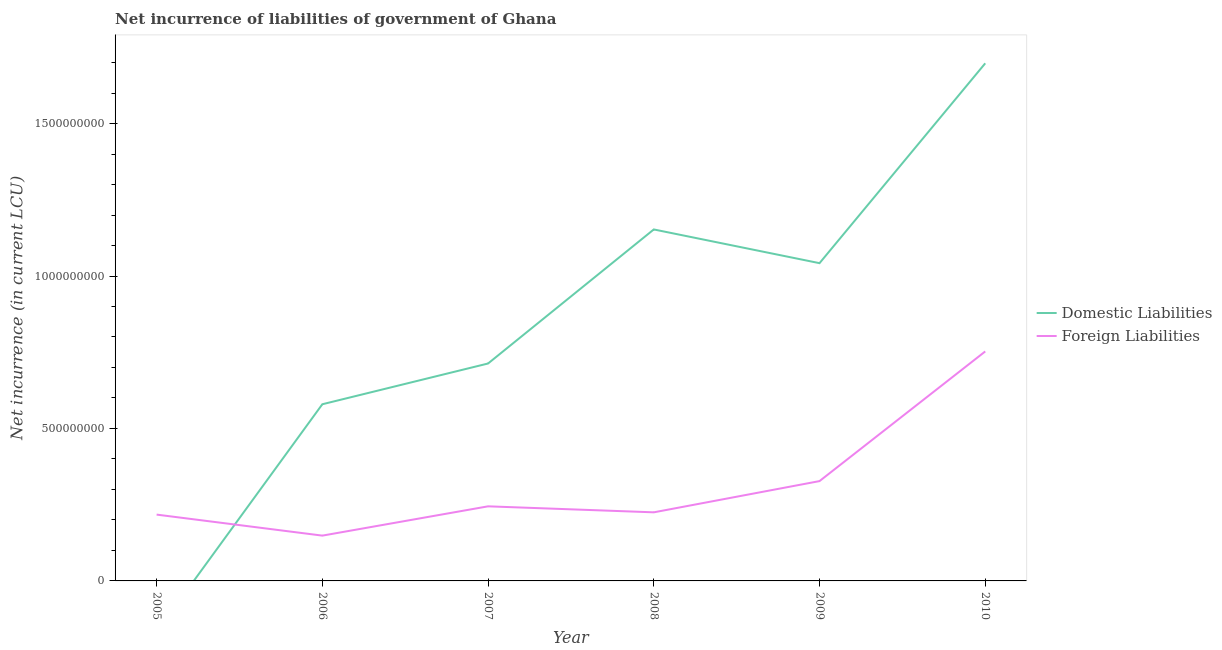How many different coloured lines are there?
Give a very brief answer. 2. Does the line corresponding to net incurrence of foreign liabilities intersect with the line corresponding to net incurrence of domestic liabilities?
Make the answer very short. Yes. Is the number of lines equal to the number of legend labels?
Your answer should be very brief. No. What is the net incurrence of foreign liabilities in 2005?
Offer a very short reply. 2.17e+08. Across all years, what is the maximum net incurrence of domestic liabilities?
Provide a succinct answer. 1.70e+09. Across all years, what is the minimum net incurrence of foreign liabilities?
Ensure brevity in your answer.  1.49e+08. In which year was the net incurrence of domestic liabilities maximum?
Your response must be concise. 2010. What is the total net incurrence of domestic liabilities in the graph?
Your answer should be compact. 5.18e+09. What is the difference between the net incurrence of foreign liabilities in 2006 and that in 2009?
Offer a very short reply. -1.79e+08. What is the difference between the net incurrence of foreign liabilities in 2009 and the net incurrence of domestic liabilities in 2010?
Keep it short and to the point. -1.37e+09. What is the average net incurrence of foreign liabilities per year?
Your answer should be compact. 3.19e+08. In the year 2010, what is the difference between the net incurrence of domestic liabilities and net incurrence of foreign liabilities?
Offer a terse response. 9.45e+08. In how many years, is the net incurrence of domestic liabilities greater than 500000000 LCU?
Your answer should be very brief. 5. What is the ratio of the net incurrence of domestic liabilities in 2007 to that in 2010?
Give a very brief answer. 0.42. Is the net incurrence of foreign liabilities in 2005 less than that in 2007?
Ensure brevity in your answer.  Yes. Is the difference between the net incurrence of domestic liabilities in 2006 and 2009 greater than the difference between the net incurrence of foreign liabilities in 2006 and 2009?
Provide a short and direct response. No. What is the difference between the highest and the second highest net incurrence of domestic liabilities?
Keep it short and to the point. 5.45e+08. What is the difference between the highest and the lowest net incurrence of domestic liabilities?
Keep it short and to the point. 1.70e+09. In how many years, is the net incurrence of foreign liabilities greater than the average net incurrence of foreign liabilities taken over all years?
Your response must be concise. 2. Is the net incurrence of domestic liabilities strictly greater than the net incurrence of foreign liabilities over the years?
Your answer should be very brief. No. Is the net incurrence of domestic liabilities strictly less than the net incurrence of foreign liabilities over the years?
Your response must be concise. No. How many lines are there?
Offer a very short reply. 2. How many years are there in the graph?
Keep it short and to the point. 6. How many legend labels are there?
Offer a terse response. 2. What is the title of the graph?
Your response must be concise. Net incurrence of liabilities of government of Ghana. Does "Non-resident workers" appear as one of the legend labels in the graph?
Your answer should be compact. No. What is the label or title of the X-axis?
Offer a very short reply. Year. What is the label or title of the Y-axis?
Make the answer very short. Net incurrence (in current LCU). What is the Net incurrence (in current LCU) of Foreign Liabilities in 2005?
Provide a succinct answer. 2.17e+08. What is the Net incurrence (in current LCU) in Domestic Liabilities in 2006?
Offer a terse response. 5.79e+08. What is the Net incurrence (in current LCU) of Foreign Liabilities in 2006?
Give a very brief answer. 1.49e+08. What is the Net incurrence (in current LCU) in Domestic Liabilities in 2007?
Make the answer very short. 7.13e+08. What is the Net incurrence (in current LCU) in Foreign Liabilities in 2007?
Your answer should be compact. 2.45e+08. What is the Net incurrence (in current LCU) in Domestic Liabilities in 2008?
Keep it short and to the point. 1.15e+09. What is the Net incurrence (in current LCU) in Foreign Liabilities in 2008?
Provide a short and direct response. 2.25e+08. What is the Net incurrence (in current LCU) in Domestic Liabilities in 2009?
Offer a terse response. 1.04e+09. What is the Net incurrence (in current LCU) of Foreign Liabilities in 2009?
Offer a very short reply. 3.27e+08. What is the Net incurrence (in current LCU) in Domestic Liabilities in 2010?
Provide a short and direct response. 1.70e+09. What is the Net incurrence (in current LCU) of Foreign Liabilities in 2010?
Keep it short and to the point. 7.53e+08. Across all years, what is the maximum Net incurrence (in current LCU) of Domestic Liabilities?
Offer a very short reply. 1.70e+09. Across all years, what is the maximum Net incurrence (in current LCU) in Foreign Liabilities?
Give a very brief answer. 7.53e+08. Across all years, what is the minimum Net incurrence (in current LCU) of Domestic Liabilities?
Give a very brief answer. 0. Across all years, what is the minimum Net incurrence (in current LCU) in Foreign Liabilities?
Offer a terse response. 1.49e+08. What is the total Net incurrence (in current LCU) of Domestic Liabilities in the graph?
Make the answer very short. 5.18e+09. What is the total Net incurrence (in current LCU) in Foreign Liabilities in the graph?
Provide a succinct answer. 1.92e+09. What is the difference between the Net incurrence (in current LCU) in Foreign Liabilities in 2005 and that in 2006?
Your response must be concise. 6.89e+07. What is the difference between the Net incurrence (in current LCU) in Foreign Liabilities in 2005 and that in 2007?
Make the answer very short. -2.72e+07. What is the difference between the Net incurrence (in current LCU) in Foreign Liabilities in 2005 and that in 2008?
Give a very brief answer. -7.49e+06. What is the difference between the Net incurrence (in current LCU) in Foreign Liabilities in 2005 and that in 2009?
Offer a terse response. -1.10e+08. What is the difference between the Net incurrence (in current LCU) of Foreign Liabilities in 2005 and that in 2010?
Make the answer very short. -5.35e+08. What is the difference between the Net incurrence (in current LCU) in Domestic Liabilities in 2006 and that in 2007?
Your answer should be compact. -1.34e+08. What is the difference between the Net incurrence (in current LCU) in Foreign Liabilities in 2006 and that in 2007?
Your response must be concise. -9.61e+07. What is the difference between the Net incurrence (in current LCU) in Domestic Liabilities in 2006 and that in 2008?
Your answer should be very brief. -5.73e+08. What is the difference between the Net incurrence (in current LCU) of Foreign Liabilities in 2006 and that in 2008?
Offer a terse response. -7.64e+07. What is the difference between the Net incurrence (in current LCU) in Domestic Liabilities in 2006 and that in 2009?
Provide a short and direct response. -4.63e+08. What is the difference between the Net incurrence (in current LCU) of Foreign Liabilities in 2006 and that in 2009?
Make the answer very short. -1.79e+08. What is the difference between the Net incurrence (in current LCU) of Domestic Liabilities in 2006 and that in 2010?
Offer a very short reply. -1.12e+09. What is the difference between the Net incurrence (in current LCU) of Foreign Liabilities in 2006 and that in 2010?
Keep it short and to the point. -6.04e+08. What is the difference between the Net incurrence (in current LCU) of Domestic Liabilities in 2007 and that in 2008?
Your answer should be very brief. -4.40e+08. What is the difference between the Net incurrence (in current LCU) of Foreign Liabilities in 2007 and that in 2008?
Provide a succinct answer. 1.97e+07. What is the difference between the Net incurrence (in current LCU) in Domestic Liabilities in 2007 and that in 2009?
Your answer should be compact. -3.29e+08. What is the difference between the Net incurrence (in current LCU) of Foreign Liabilities in 2007 and that in 2009?
Make the answer very short. -8.27e+07. What is the difference between the Net incurrence (in current LCU) of Domestic Liabilities in 2007 and that in 2010?
Keep it short and to the point. -9.85e+08. What is the difference between the Net incurrence (in current LCU) in Foreign Liabilities in 2007 and that in 2010?
Keep it short and to the point. -5.08e+08. What is the difference between the Net incurrence (in current LCU) of Domestic Liabilities in 2008 and that in 2009?
Ensure brevity in your answer.  1.11e+08. What is the difference between the Net incurrence (in current LCU) of Foreign Liabilities in 2008 and that in 2009?
Your response must be concise. -1.02e+08. What is the difference between the Net incurrence (in current LCU) of Domestic Liabilities in 2008 and that in 2010?
Keep it short and to the point. -5.45e+08. What is the difference between the Net incurrence (in current LCU) of Foreign Liabilities in 2008 and that in 2010?
Ensure brevity in your answer.  -5.28e+08. What is the difference between the Net incurrence (in current LCU) of Domestic Liabilities in 2009 and that in 2010?
Ensure brevity in your answer.  -6.55e+08. What is the difference between the Net incurrence (in current LCU) in Foreign Liabilities in 2009 and that in 2010?
Ensure brevity in your answer.  -4.25e+08. What is the difference between the Net incurrence (in current LCU) of Domestic Liabilities in 2006 and the Net incurrence (in current LCU) of Foreign Liabilities in 2007?
Provide a succinct answer. 3.35e+08. What is the difference between the Net incurrence (in current LCU) of Domestic Liabilities in 2006 and the Net incurrence (in current LCU) of Foreign Liabilities in 2008?
Offer a very short reply. 3.54e+08. What is the difference between the Net incurrence (in current LCU) of Domestic Liabilities in 2006 and the Net incurrence (in current LCU) of Foreign Liabilities in 2009?
Provide a short and direct response. 2.52e+08. What is the difference between the Net incurrence (in current LCU) in Domestic Liabilities in 2006 and the Net incurrence (in current LCU) in Foreign Liabilities in 2010?
Offer a terse response. -1.73e+08. What is the difference between the Net incurrence (in current LCU) in Domestic Liabilities in 2007 and the Net incurrence (in current LCU) in Foreign Liabilities in 2008?
Your answer should be compact. 4.88e+08. What is the difference between the Net incurrence (in current LCU) in Domestic Liabilities in 2007 and the Net incurrence (in current LCU) in Foreign Liabilities in 2009?
Your answer should be very brief. 3.86e+08. What is the difference between the Net incurrence (in current LCU) in Domestic Liabilities in 2007 and the Net incurrence (in current LCU) in Foreign Liabilities in 2010?
Your answer should be compact. -3.96e+07. What is the difference between the Net incurrence (in current LCU) of Domestic Liabilities in 2008 and the Net incurrence (in current LCU) of Foreign Liabilities in 2009?
Your answer should be compact. 8.25e+08. What is the difference between the Net incurrence (in current LCU) of Domestic Liabilities in 2008 and the Net incurrence (in current LCU) of Foreign Liabilities in 2010?
Give a very brief answer. 4.00e+08. What is the difference between the Net incurrence (in current LCU) of Domestic Liabilities in 2009 and the Net incurrence (in current LCU) of Foreign Liabilities in 2010?
Offer a very short reply. 2.89e+08. What is the average Net incurrence (in current LCU) in Domestic Liabilities per year?
Your answer should be very brief. 8.64e+08. What is the average Net incurrence (in current LCU) in Foreign Liabilities per year?
Your response must be concise. 3.19e+08. In the year 2006, what is the difference between the Net incurrence (in current LCU) of Domestic Liabilities and Net incurrence (in current LCU) of Foreign Liabilities?
Keep it short and to the point. 4.31e+08. In the year 2007, what is the difference between the Net incurrence (in current LCU) in Domestic Liabilities and Net incurrence (in current LCU) in Foreign Liabilities?
Give a very brief answer. 4.68e+08. In the year 2008, what is the difference between the Net incurrence (in current LCU) in Domestic Liabilities and Net incurrence (in current LCU) in Foreign Liabilities?
Provide a succinct answer. 9.28e+08. In the year 2009, what is the difference between the Net incurrence (in current LCU) of Domestic Liabilities and Net incurrence (in current LCU) of Foreign Liabilities?
Your answer should be compact. 7.15e+08. In the year 2010, what is the difference between the Net incurrence (in current LCU) in Domestic Liabilities and Net incurrence (in current LCU) in Foreign Liabilities?
Give a very brief answer. 9.45e+08. What is the ratio of the Net incurrence (in current LCU) of Foreign Liabilities in 2005 to that in 2006?
Make the answer very short. 1.46. What is the ratio of the Net incurrence (in current LCU) of Foreign Liabilities in 2005 to that in 2007?
Your answer should be very brief. 0.89. What is the ratio of the Net incurrence (in current LCU) in Foreign Liabilities in 2005 to that in 2008?
Your answer should be very brief. 0.97. What is the ratio of the Net incurrence (in current LCU) of Foreign Liabilities in 2005 to that in 2009?
Make the answer very short. 0.66. What is the ratio of the Net incurrence (in current LCU) in Foreign Liabilities in 2005 to that in 2010?
Your answer should be compact. 0.29. What is the ratio of the Net incurrence (in current LCU) of Domestic Liabilities in 2006 to that in 2007?
Offer a terse response. 0.81. What is the ratio of the Net incurrence (in current LCU) in Foreign Liabilities in 2006 to that in 2007?
Provide a short and direct response. 0.61. What is the ratio of the Net incurrence (in current LCU) in Domestic Liabilities in 2006 to that in 2008?
Offer a very short reply. 0.5. What is the ratio of the Net incurrence (in current LCU) in Foreign Liabilities in 2006 to that in 2008?
Your answer should be compact. 0.66. What is the ratio of the Net incurrence (in current LCU) of Domestic Liabilities in 2006 to that in 2009?
Make the answer very short. 0.56. What is the ratio of the Net incurrence (in current LCU) in Foreign Liabilities in 2006 to that in 2009?
Your answer should be very brief. 0.45. What is the ratio of the Net incurrence (in current LCU) of Domestic Liabilities in 2006 to that in 2010?
Make the answer very short. 0.34. What is the ratio of the Net incurrence (in current LCU) of Foreign Liabilities in 2006 to that in 2010?
Ensure brevity in your answer.  0.2. What is the ratio of the Net incurrence (in current LCU) of Domestic Liabilities in 2007 to that in 2008?
Make the answer very short. 0.62. What is the ratio of the Net incurrence (in current LCU) in Foreign Liabilities in 2007 to that in 2008?
Offer a very short reply. 1.09. What is the ratio of the Net incurrence (in current LCU) in Domestic Liabilities in 2007 to that in 2009?
Give a very brief answer. 0.68. What is the ratio of the Net incurrence (in current LCU) of Foreign Liabilities in 2007 to that in 2009?
Your response must be concise. 0.75. What is the ratio of the Net incurrence (in current LCU) of Domestic Liabilities in 2007 to that in 2010?
Your response must be concise. 0.42. What is the ratio of the Net incurrence (in current LCU) in Foreign Liabilities in 2007 to that in 2010?
Provide a short and direct response. 0.33. What is the ratio of the Net incurrence (in current LCU) of Domestic Liabilities in 2008 to that in 2009?
Provide a succinct answer. 1.11. What is the ratio of the Net incurrence (in current LCU) in Foreign Liabilities in 2008 to that in 2009?
Offer a very short reply. 0.69. What is the ratio of the Net incurrence (in current LCU) in Domestic Liabilities in 2008 to that in 2010?
Your answer should be compact. 0.68. What is the ratio of the Net incurrence (in current LCU) of Foreign Liabilities in 2008 to that in 2010?
Your response must be concise. 0.3. What is the ratio of the Net incurrence (in current LCU) in Domestic Liabilities in 2009 to that in 2010?
Your answer should be compact. 0.61. What is the ratio of the Net incurrence (in current LCU) of Foreign Liabilities in 2009 to that in 2010?
Offer a very short reply. 0.43. What is the difference between the highest and the second highest Net incurrence (in current LCU) in Domestic Liabilities?
Your response must be concise. 5.45e+08. What is the difference between the highest and the second highest Net incurrence (in current LCU) in Foreign Liabilities?
Provide a short and direct response. 4.25e+08. What is the difference between the highest and the lowest Net incurrence (in current LCU) of Domestic Liabilities?
Provide a short and direct response. 1.70e+09. What is the difference between the highest and the lowest Net incurrence (in current LCU) in Foreign Liabilities?
Your answer should be very brief. 6.04e+08. 